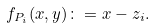<formula> <loc_0><loc_0><loc_500><loc_500>f _ { P _ { i } } ( x , y ) \colon = x - z _ { i } .</formula> 